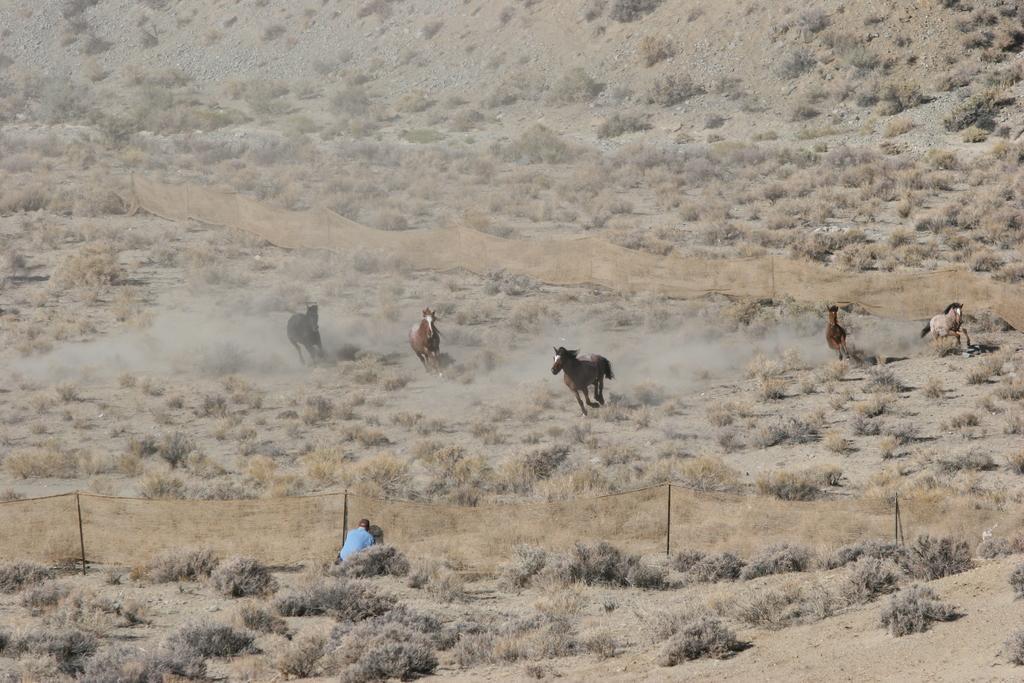How would you summarize this image in a sentence or two? In this image we can see one person sitting and few animals, dried grass, rocks, fencing. 